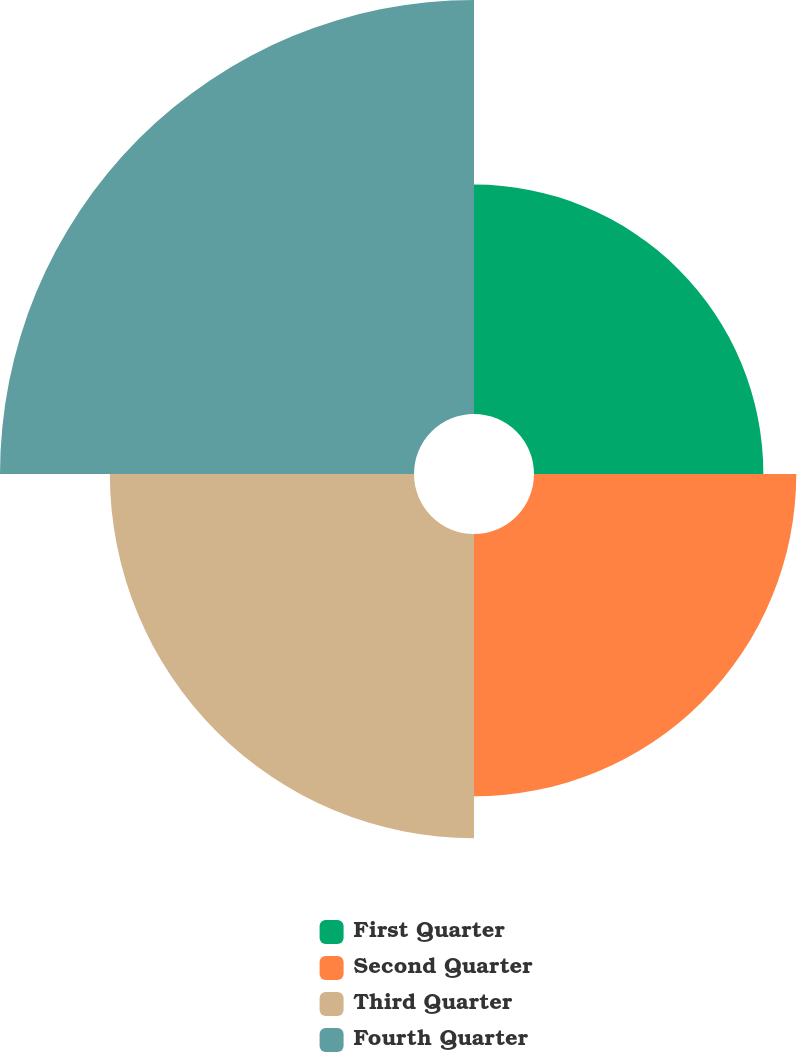Convert chart to OTSL. <chart><loc_0><loc_0><loc_500><loc_500><pie_chart><fcel>First Quarter<fcel>Second Quarter<fcel>Third Quarter<fcel>Fourth Quarter<nl><fcel>18.96%<fcel>21.68%<fcel>25.14%<fcel>34.22%<nl></chart> 